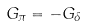<formula> <loc_0><loc_0><loc_500><loc_500>G _ { \pi } = - G _ { \delta }</formula> 